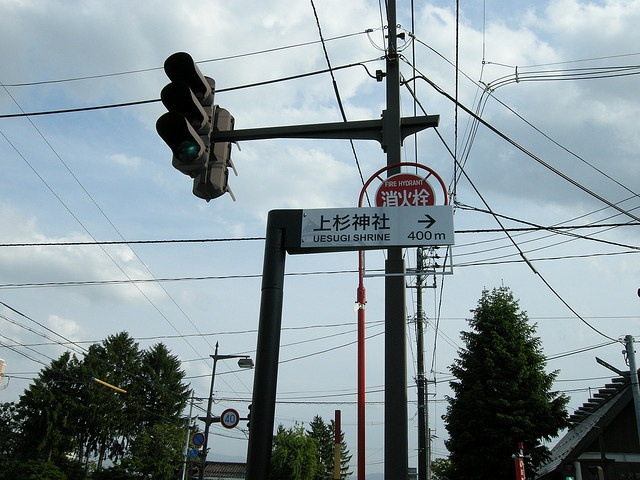Describe the objects in this image and their specific colors. I can see traffic light in lightgray, black, and gray tones and traffic light in lightgray, black, gray, and darkgray tones in this image. 